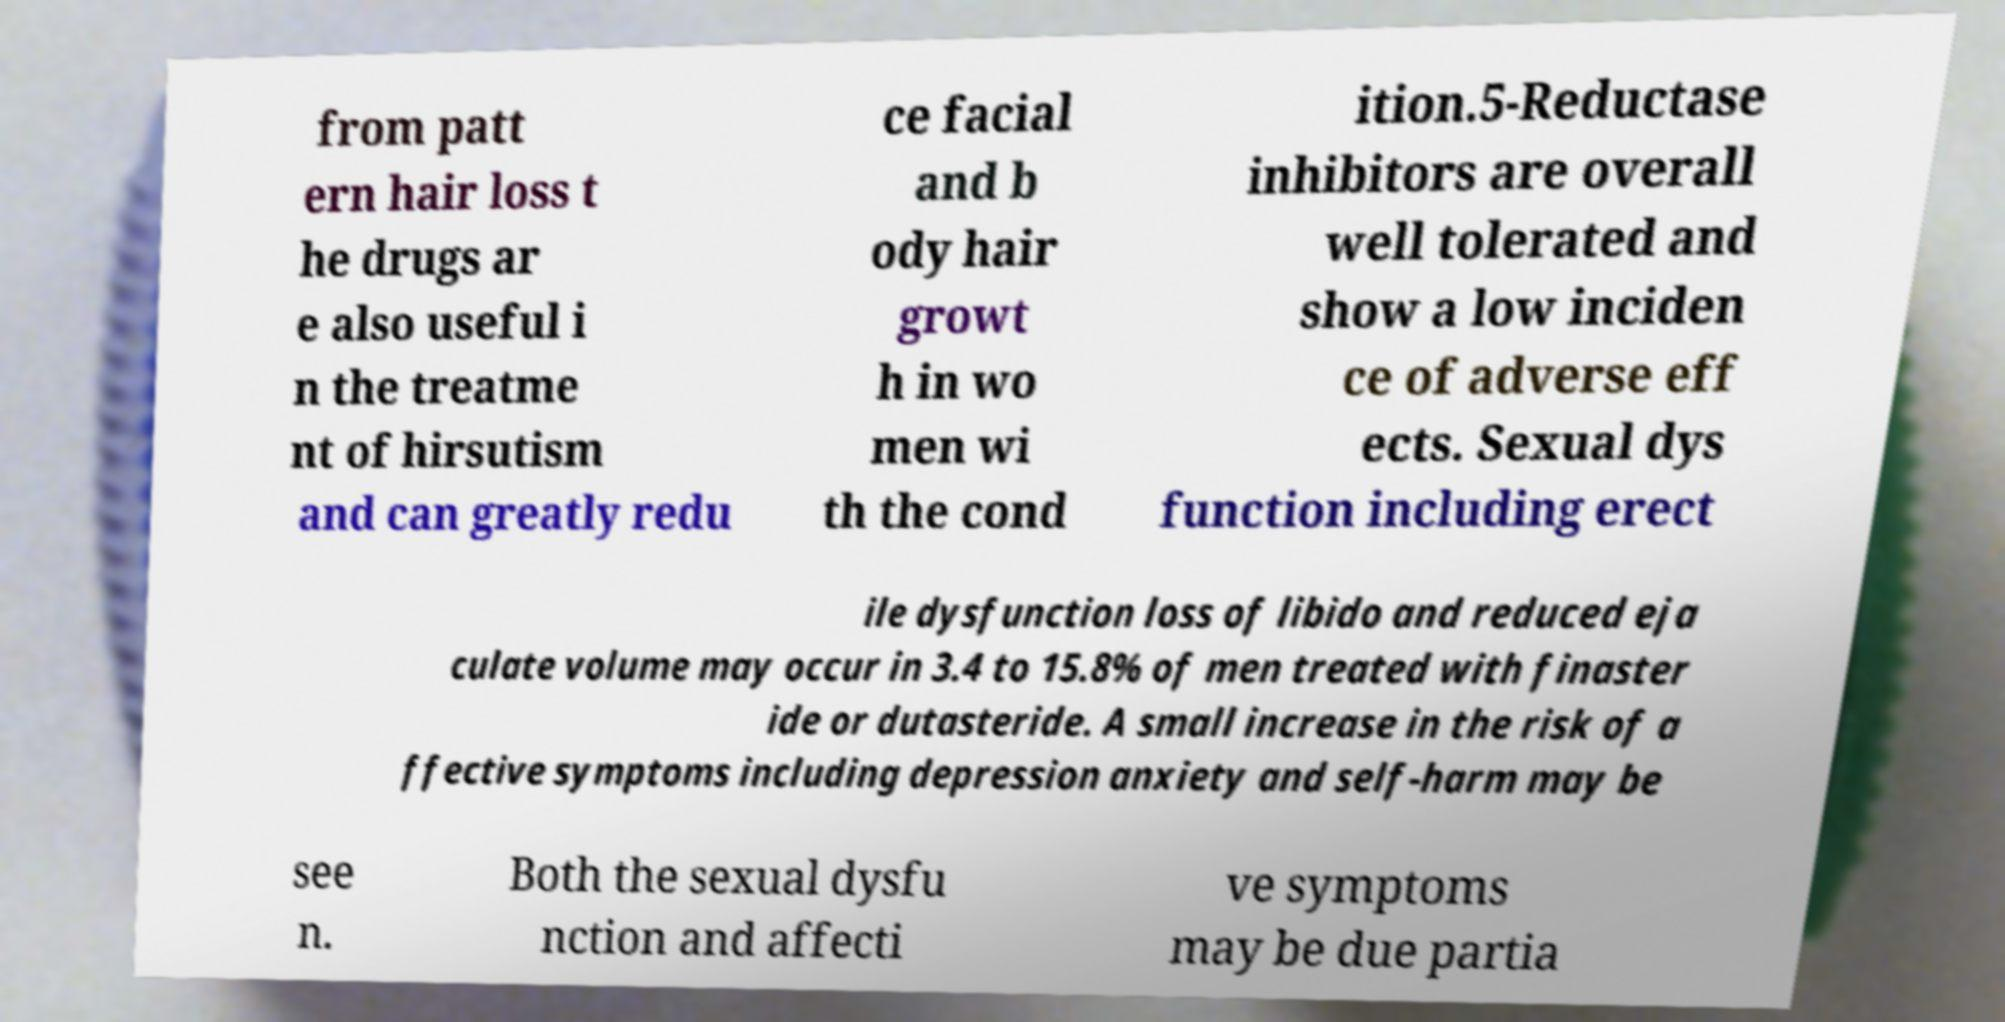Please identify and transcribe the text found in this image. from patt ern hair loss t he drugs ar e also useful i n the treatme nt of hirsutism and can greatly redu ce facial and b ody hair growt h in wo men wi th the cond ition.5-Reductase inhibitors are overall well tolerated and show a low inciden ce of adverse eff ects. Sexual dys function including erect ile dysfunction loss of libido and reduced eja culate volume may occur in 3.4 to 15.8% of men treated with finaster ide or dutasteride. A small increase in the risk of a ffective symptoms including depression anxiety and self-harm may be see n. Both the sexual dysfu nction and affecti ve symptoms may be due partia 